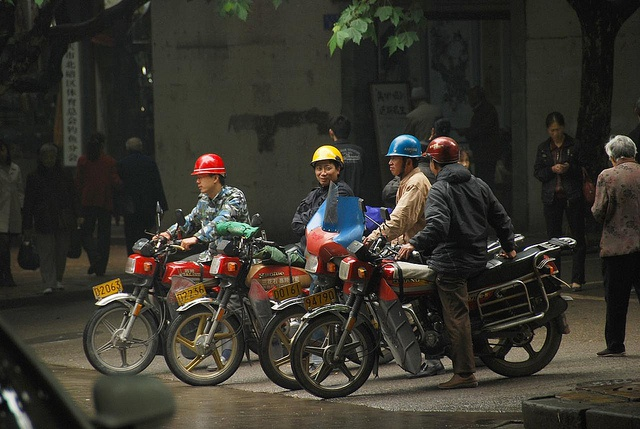Describe the objects in this image and their specific colors. I can see motorcycle in black, gray, and maroon tones, people in black, gray, maroon, and brown tones, motorcycle in black, gray, and maroon tones, motorcycle in black, gray, and maroon tones, and car in black, darkgreen, and gray tones in this image. 